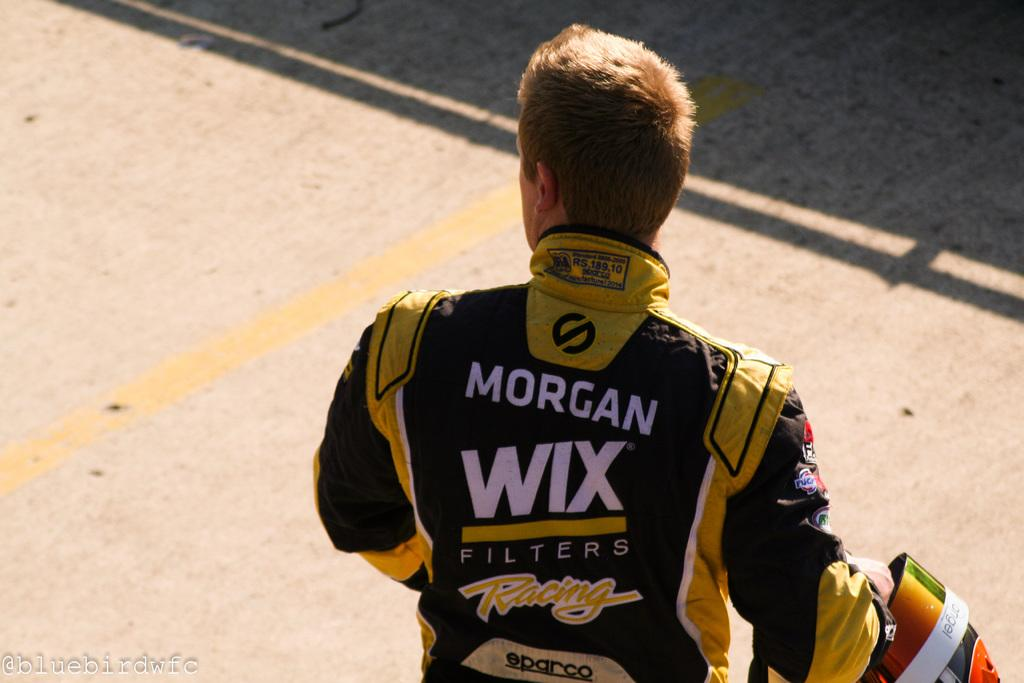<image>
Render a clear and concise summary of the photo. A race car drive sponsored by Morgan Wix stands holding his helmet as he looks into the distance. 